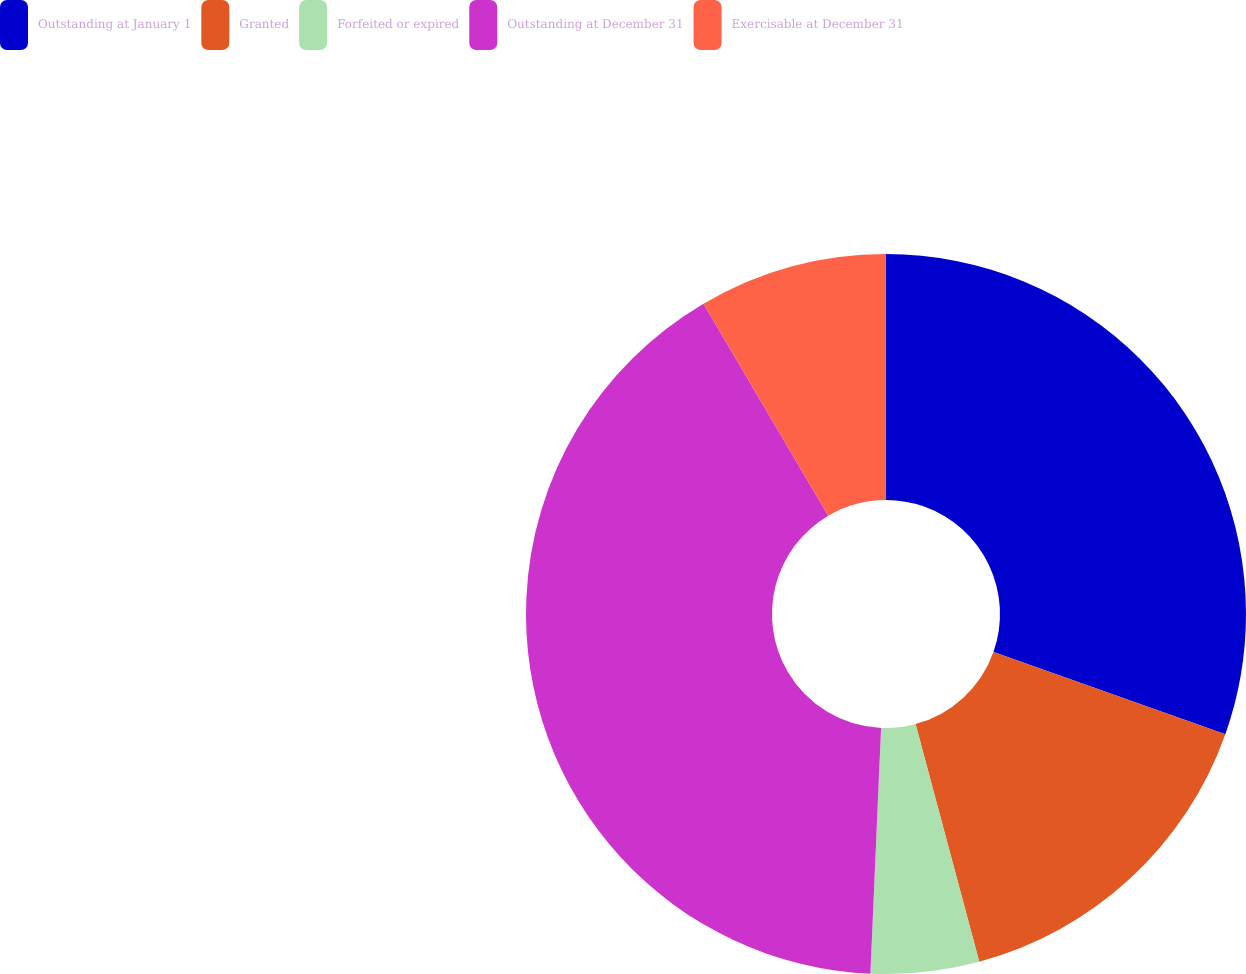Convert chart to OTSL. <chart><loc_0><loc_0><loc_500><loc_500><pie_chart><fcel>Outstanding at January 1<fcel>Granted<fcel>Forfeited or expired<fcel>Outstanding at December 31<fcel>Exercisable at December 31<nl><fcel>30.42%<fcel>15.41%<fcel>4.86%<fcel>40.85%<fcel>8.46%<nl></chart> 